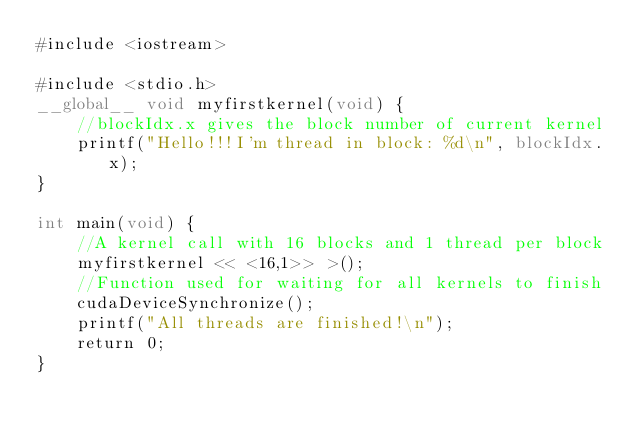<code> <loc_0><loc_0><loc_500><loc_500><_Cuda_>#include <iostream>

#include <stdio.h>
__global__ void myfirstkernel(void) {
    //blockIdx.x gives the block number of current kernel
    printf("Hello!!!I'm thread in block: %d\n", blockIdx.x);
}

int main(void) {
    //A kernel call with 16 blocks and 1 thread per block
    myfirstkernel << <16,1>> >();
    //Function used for waiting for all kernels to finish
    cudaDeviceSynchronize();
    printf("All threads are finished!\n");
    return 0;
}
</code> 